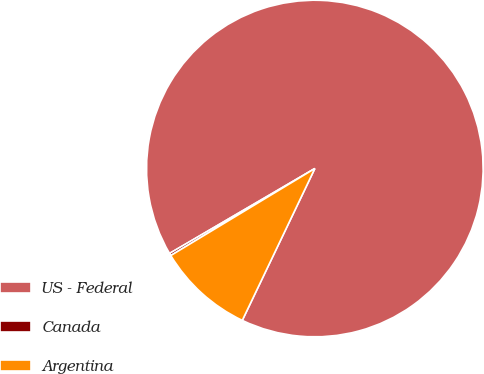<chart> <loc_0><loc_0><loc_500><loc_500><pie_chart><fcel>US - Federal<fcel>Canada<fcel>Argentina<nl><fcel>90.52%<fcel>0.23%<fcel>9.26%<nl></chart> 